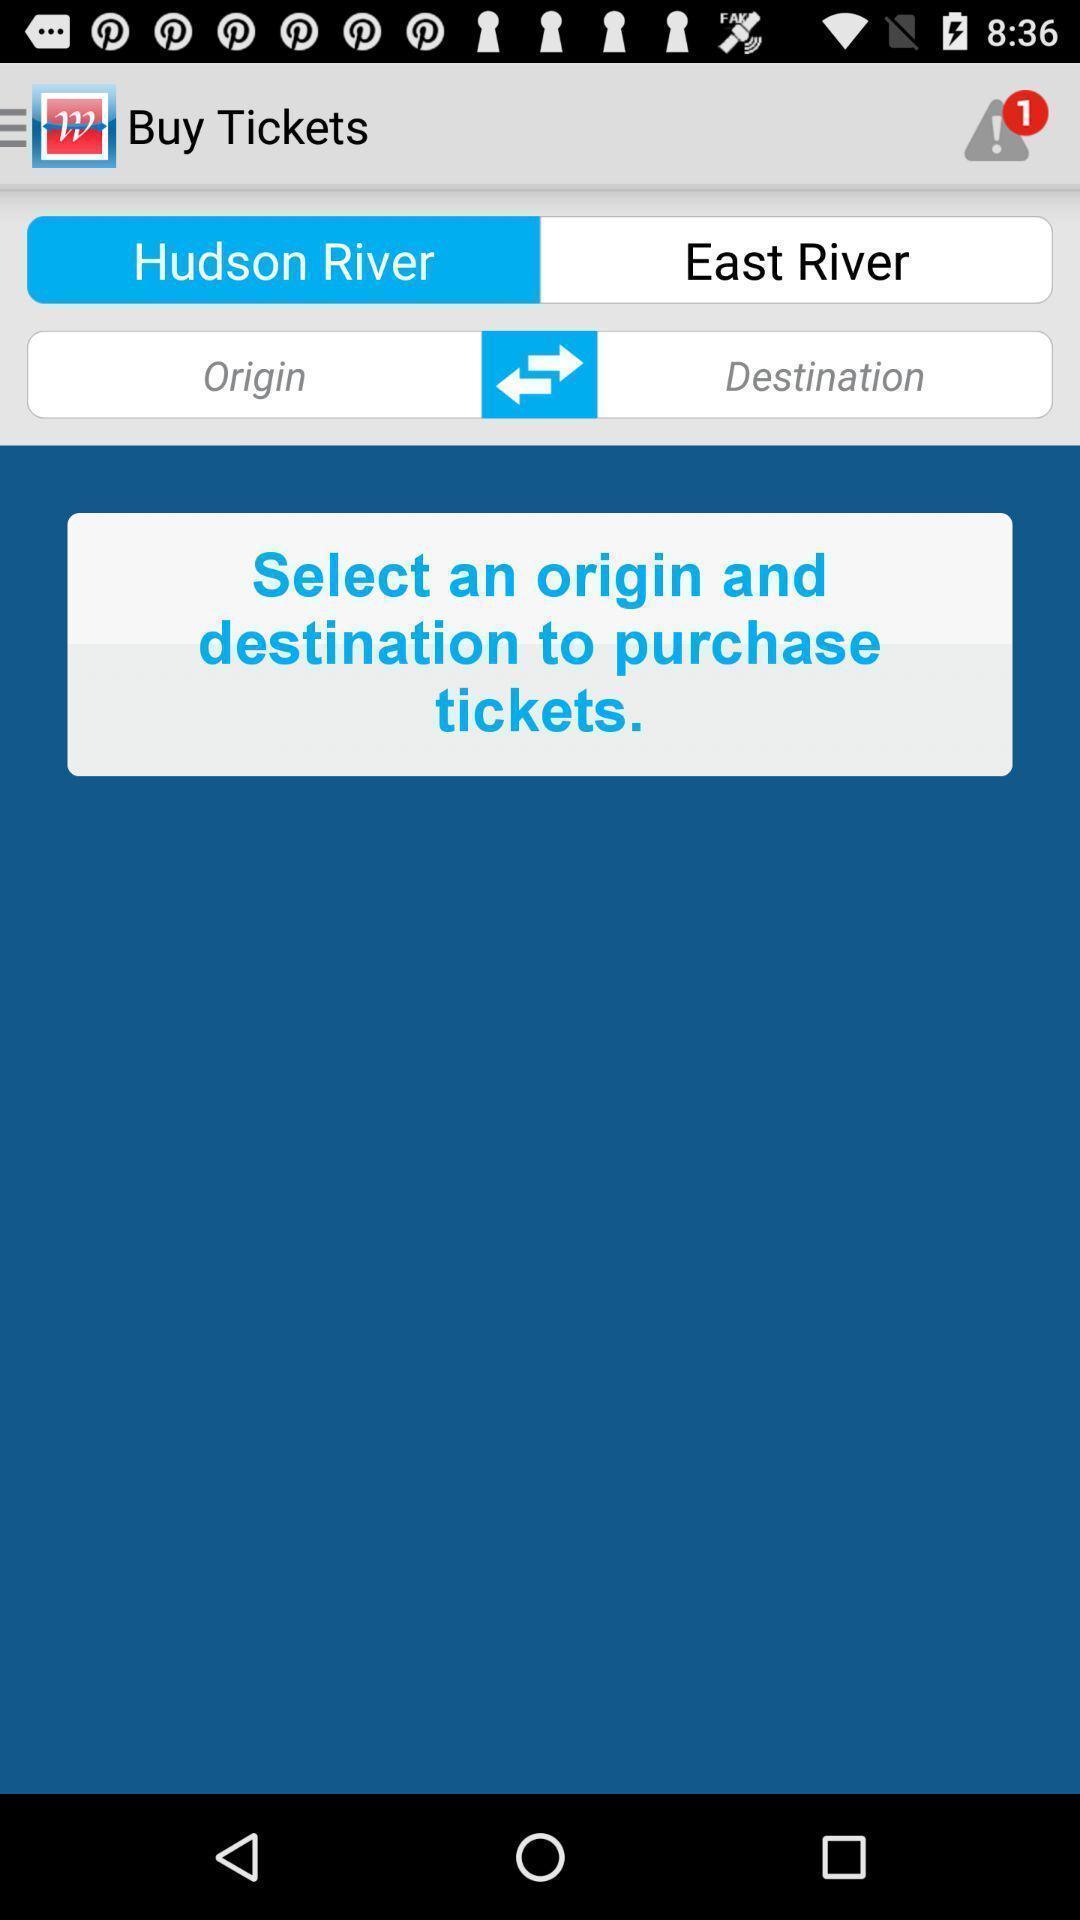What can you discern from this picture? Ticket booking page. 